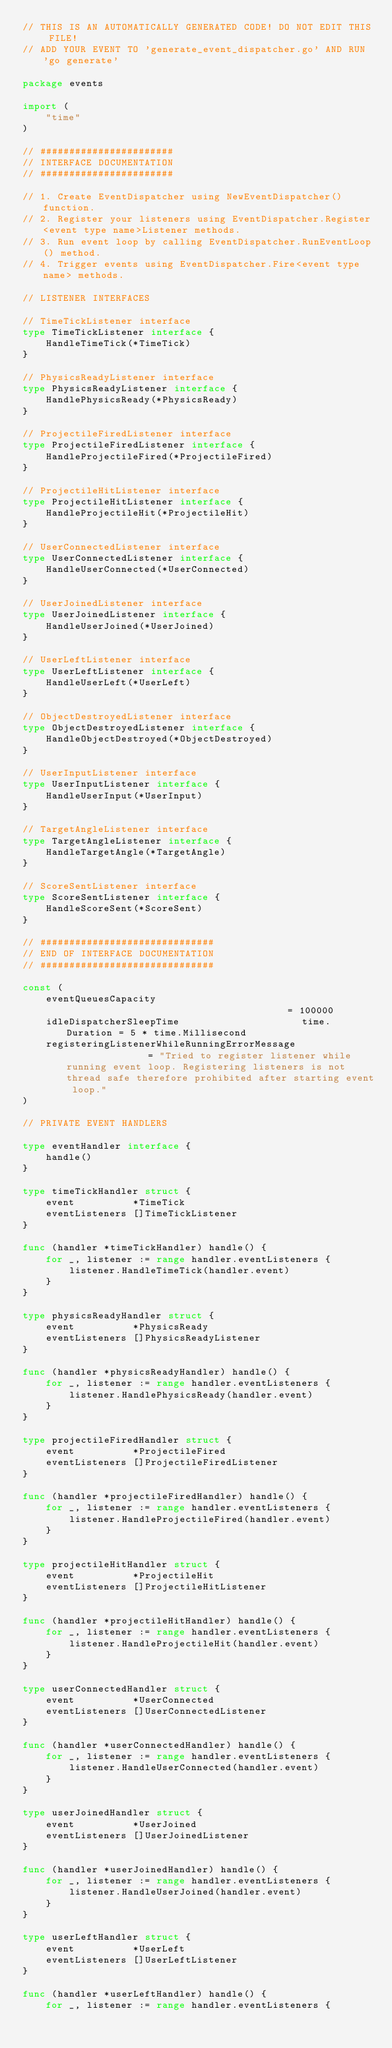<code> <loc_0><loc_0><loc_500><loc_500><_Go_>// THIS IS AN AUTOMATICALLY GENERATED CODE! DO NOT EDIT THIS FILE!
// ADD YOUR EVENT TO 'generate_event_dispatcher.go' AND RUN 'go generate'

package events

import (
	"time"
)

// #######################
// INTERFACE DOCUMENTATION
// #######################

// 1. Create EventDispatcher using NewEventDispatcher() function.
// 2. Register your listeners using EventDispatcher.Register<event type name>Listener methods.
// 3. Run event loop by calling EventDispatcher.RunEventLoop() method.
// 4. Trigger events using EventDispatcher.Fire<event type name> methods.

// LISTENER INTERFACES

// TimeTickListener interface
type TimeTickListener interface {
	HandleTimeTick(*TimeTick)
}

// PhysicsReadyListener interface
type PhysicsReadyListener interface {
	HandlePhysicsReady(*PhysicsReady)
}

// ProjectileFiredListener interface
type ProjectileFiredListener interface {
	HandleProjectileFired(*ProjectileFired)
}

// ProjectileHitListener interface
type ProjectileHitListener interface {
	HandleProjectileHit(*ProjectileHit)
}

// UserConnectedListener interface
type UserConnectedListener interface {
	HandleUserConnected(*UserConnected)
}

// UserJoinedListener interface
type UserJoinedListener interface {
	HandleUserJoined(*UserJoined)
}

// UserLeftListener interface
type UserLeftListener interface {
	HandleUserLeft(*UserLeft)
}

// ObjectDestroyedListener interface
type ObjectDestroyedListener interface {
	HandleObjectDestroyed(*ObjectDestroyed)
}

// UserInputListener interface
type UserInputListener interface {
	HandleUserInput(*UserInput)
}

// TargetAngleListener interface
type TargetAngleListener interface {
	HandleTargetAngle(*TargetAngle)
}

// ScoreSentListener interface
type ScoreSentListener interface {
	HandleScoreSent(*ScoreSent)
}

// ##############################
// END OF INTERFACE DOCUMENTATION
// ##############################

const (
	eventQueuesCapacity                                       = 100000
	idleDispatcherSleepTime                     time.Duration = 5 * time.Millisecond
	registeringListenerWhileRunningErrorMessage               = "Tried to register listener while running event loop. Registering listeners is not thread safe therefore prohibited after starting event loop."
)

// PRIVATE EVENT HANDLERS

type eventHandler interface {
	handle()
}

type timeTickHandler struct {
	event          *TimeTick
	eventListeners []TimeTickListener
}

func (handler *timeTickHandler) handle() {
	for _, listener := range handler.eventListeners {
		listener.HandleTimeTick(handler.event)
	}
}

type physicsReadyHandler struct {
	event          *PhysicsReady
	eventListeners []PhysicsReadyListener
}

func (handler *physicsReadyHandler) handle() {
	for _, listener := range handler.eventListeners {
		listener.HandlePhysicsReady(handler.event)
	}
}

type projectileFiredHandler struct {
	event          *ProjectileFired
	eventListeners []ProjectileFiredListener
}

func (handler *projectileFiredHandler) handle() {
	for _, listener := range handler.eventListeners {
		listener.HandleProjectileFired(handler.event)
	}
}

type projectileHitHandler struct {
	event          *ProjectileHit
	eventListeners []ProjectileHitListener
}

func (handler *projectileHitHandler) handle() {
	for _, listener := range handler.eventListeners {
		listener.HandleProjectileHit(handler.event)
	}
}

type userConnectedHandler struct {
	event          *UserConnected
	eventListeners []UserConnectedListener
}

func (handler *userConnectedHandler) handle() {
	for _, listener := range handler.eventListeners {
		listener.HandleUserConnected(handler.event)
	}
}

type userJoinedHandler struct {
	event          *UserJoined
	eventListeners []UserJoinedListener
}

func (handler *userJoinedHandler) handle() {
	for _, listener := range handler.eventListeners {
		listener.HandleUserJoined(handler.event)
	}
}

type userLeftHandler struct {
	event          *UserLeft
	eventListeners []UserLeftListener
}

func (handler *userLeftHandler) handle() {
	for _, listener := range handler.eventListeners {</code> 